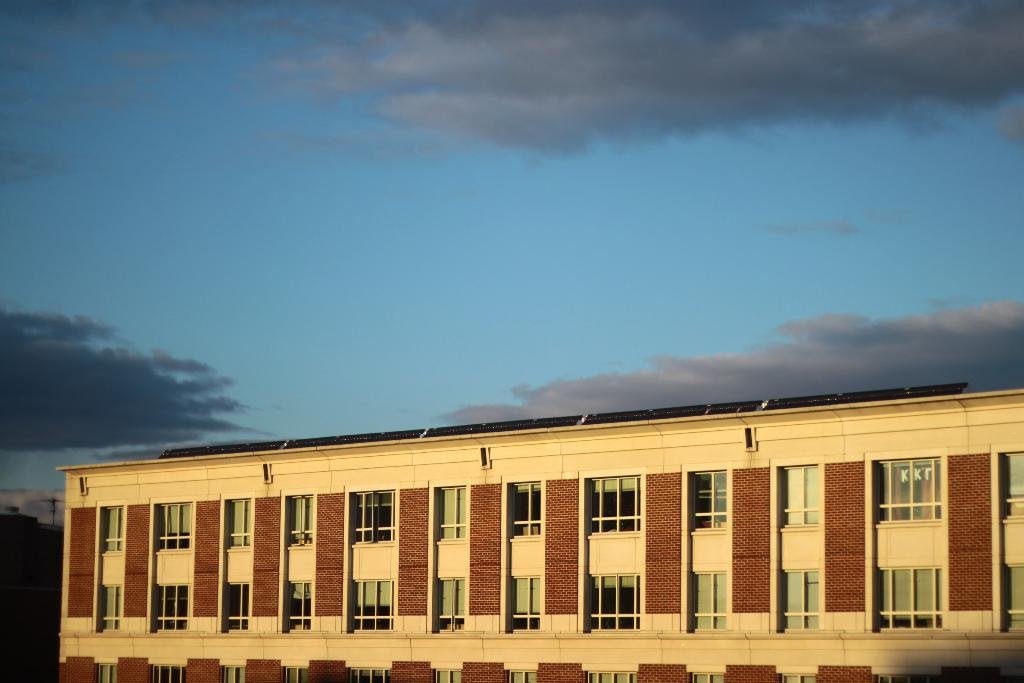What is the main subject of the image? The main subject of the image is a building. What specific features can be observed on the building? The building has windows. What can be seen in the background of the image? The sky is visible in the background of the image. How many thumbs can be seen on the building in the image? There are no thumbs present on the building in the image. What type of cart is parked next to the building in the image? There is no cart present next to the building in the image. 